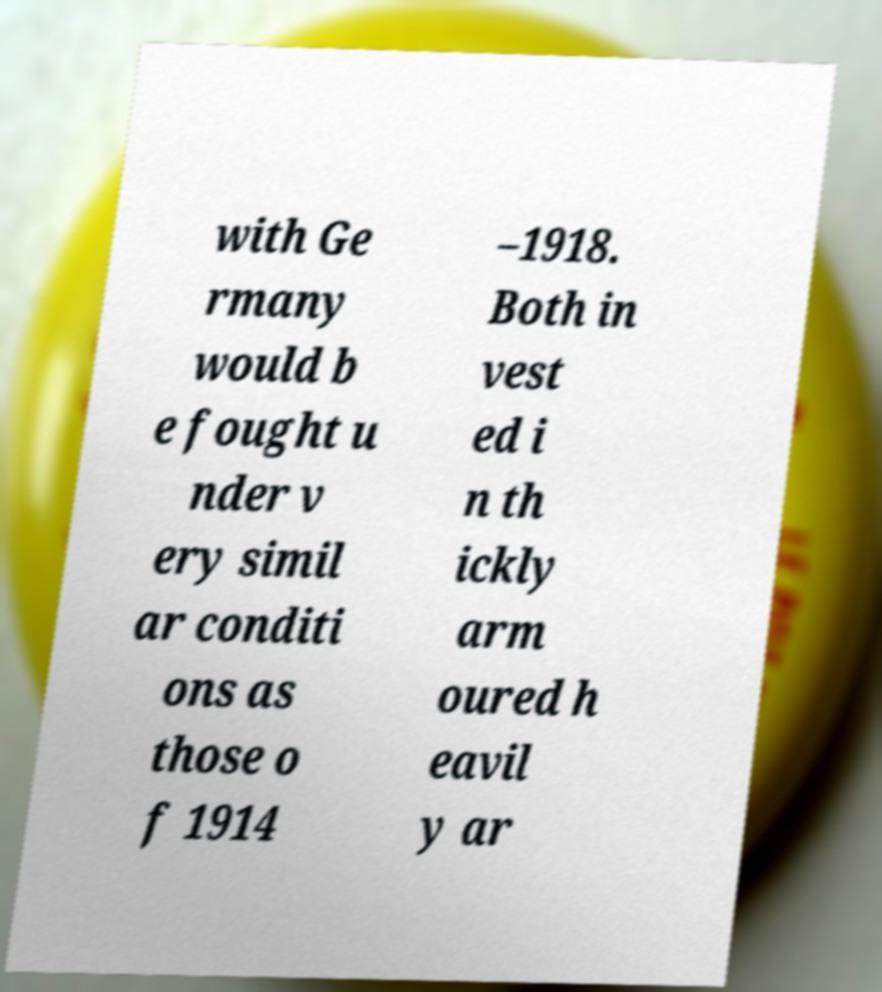For documentation purposes, I need the text within this image transcribed. Could you provide that? with Ge rmany would b e fought u nder v ery simil ar conditi ons as those o f 1914 –1918. Both in vest ed i n th ickly arm oured h eavil y ar 